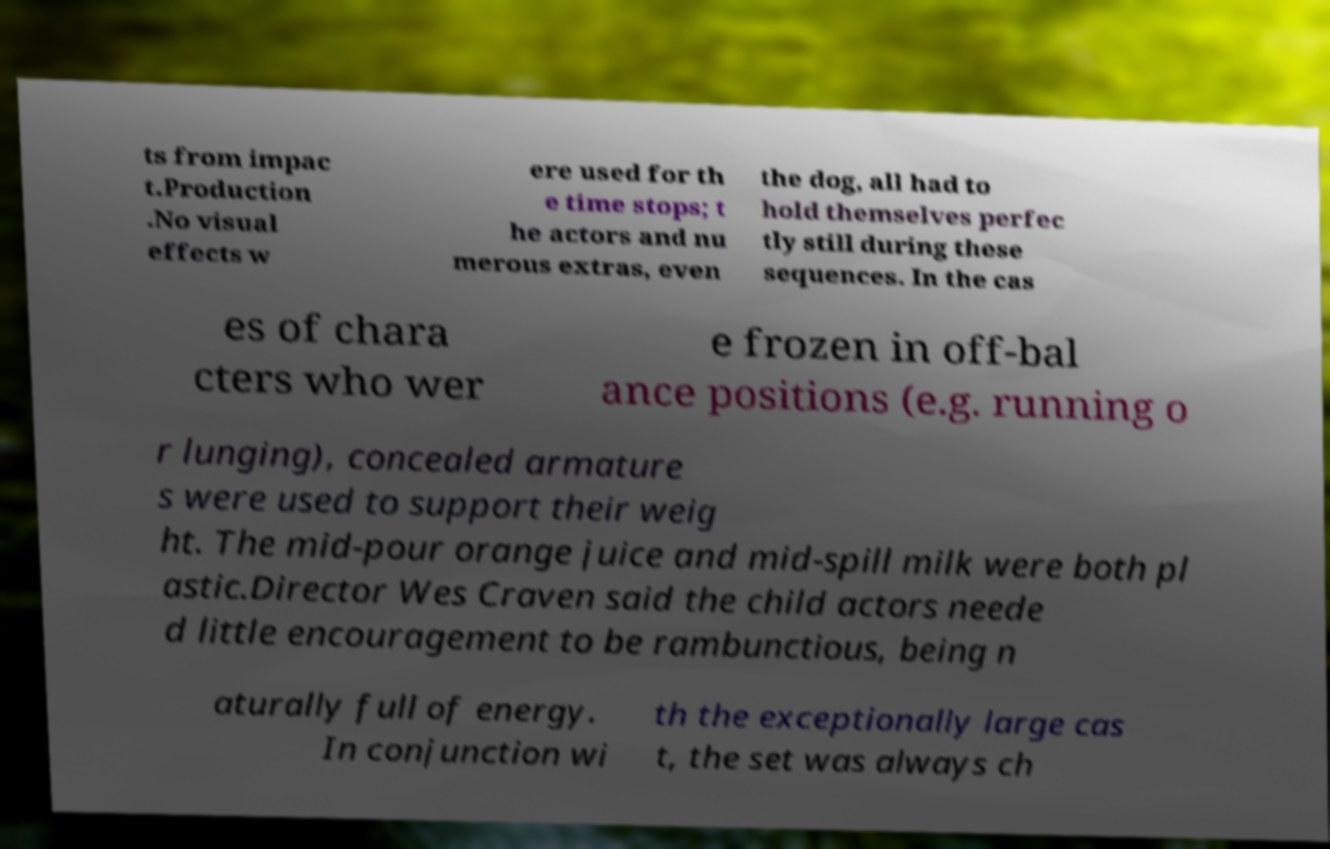For documentation purposes, I need the text within this image transcribed. Could you provide that? ts from impac t.Production .No visual effects w ere used for th e time stops; t he actors and nu merous extras, even the dog, all had to hold themselves perfec tly still during these sequences. In the cas es of chara cters who wer e frozen in off-bal ance positions (e.g. running o r lunging), concealed armature s were used to support their weig ht. The mid-pour orange juice and mid-spill milk were both pl astic.Director Wes Craven said the child actors neede d little encouragement to be rambunctious, being n aturally full of energy. In conjunction wi th the exceptionally large cas t, the set was always ch 